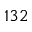Convert formula to latex. <formula><loc_0><loc_0><loc_500><loc_500>1 3 2</formula> 